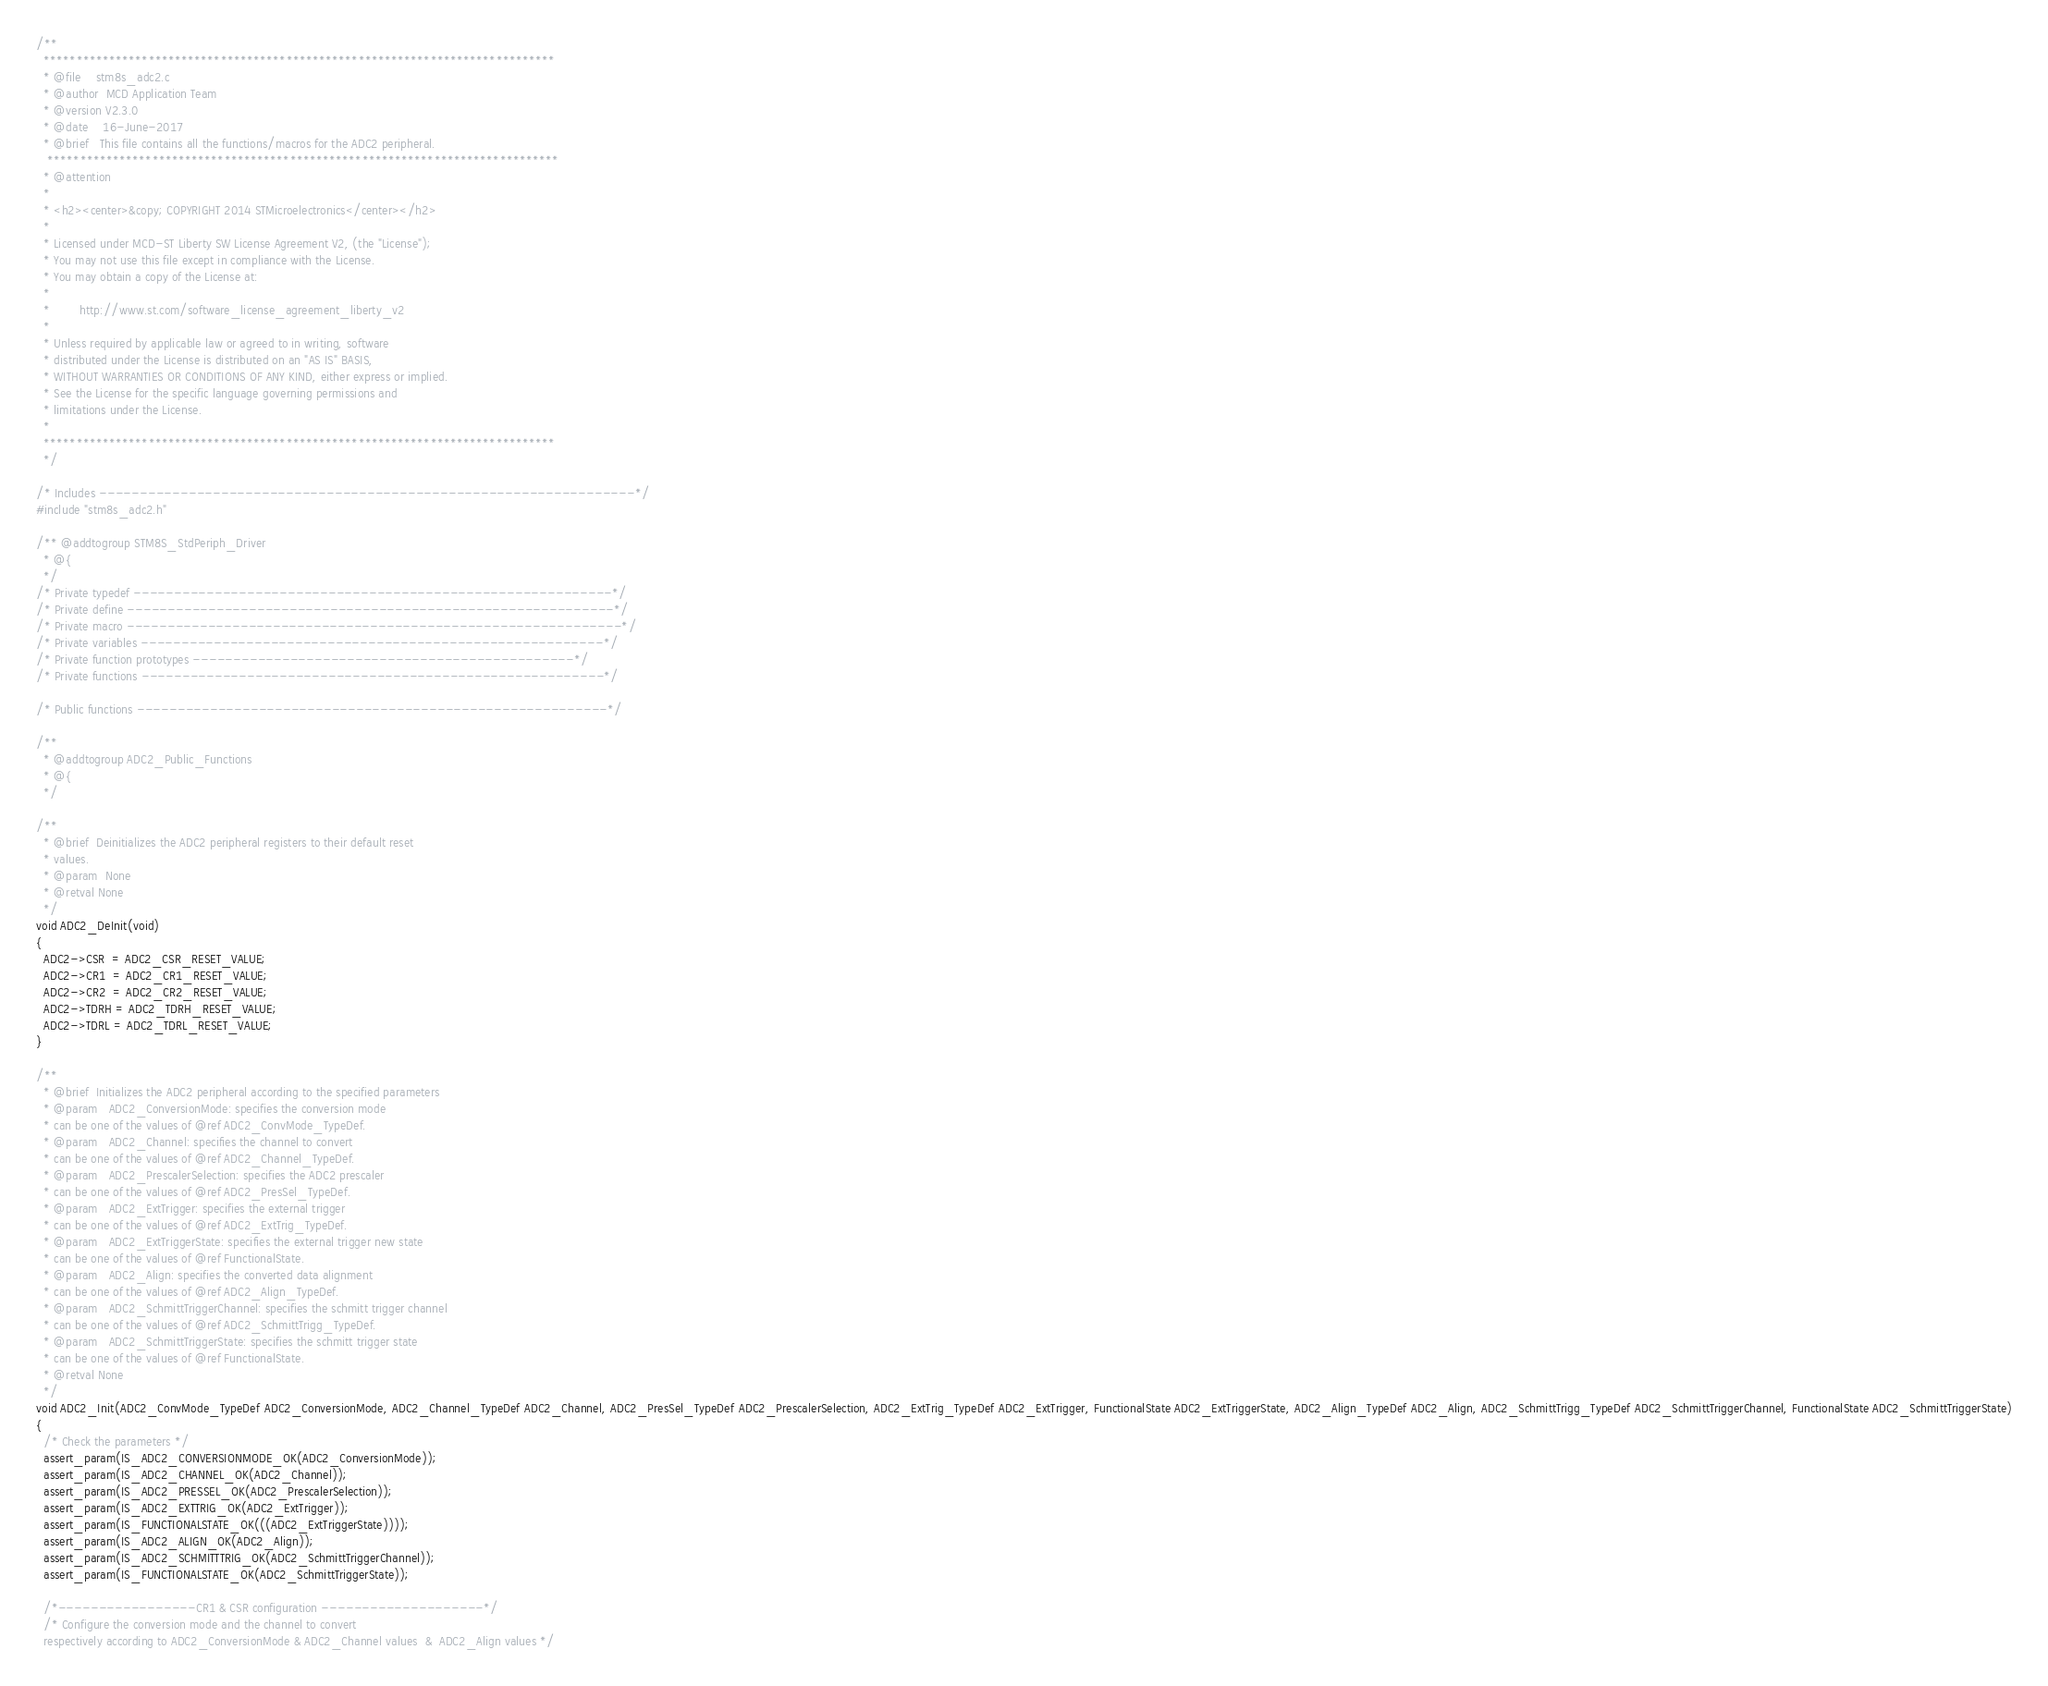<code> <loc_0><loc_0><loc_500><loc_500><_C_>/**
  ******************************************************************************
  * @file    stm8s_adc2.c
  * @author  MCD Application Team
  * @version V2.3.0
  * @date    16-June-2017
  * @brief   This file contains all the functions/macros for the ADC2 peripheral.
   ******************************************************************************
  * @attention
  *
  * <h2><center>&copy; COPYRIGHT 2014 STMicroelectronics</center></h2>
  *
  * Licensed under MCD-ST Liberty SW License Agreement V2, (the "License");
  * You may not use this file except in compliance with the License.
  * You may obtain a copy of the License at:
  *
  *        http://www.st.com/software_license_agreement_liberty_v2
  *
  * Unless required by applicable law or agreed to in writing, software 
  * distributed under the License is distributed on an "AS IS" BASIS, 
  * WITHOUT WARRANTIES OR CONDITIONS OF ANY KIND, either express or implied.
  * See the License for the specific language governing permissions and
  * limitations under the License.
  *
  ******************************************************************************
  */

/* Includes ------------------------------------------------------------------*/
#include "stm8s_adc2.h"

/** @addtogroup STM8S_StdPeriph_Driver
  * @{
  */
/* Private typedef -----------------------------------------------------------*/
/* Private define ------------------------------------------------------------*/
/* Private macro -------------------------------------------------------------*/
/* Private variables ---------------------------------------------------------*/
/* Private function prototypes -----------------------------------------------*/
/* Private functions ---------------------------------------------------------*/

/* Public functions ----------------------------------------------------------*/

/**
  * @addtogroup ADC2_Public_Functions
  * @{
  */

/**
  * @brief  Deinitializes the ADC2 peripheral registers to their default reset
  * values.
  * @param  None
  * @retval None
  */
void ADC2_DeInit(void)
{
  ADC2->CSR  = ADC2_CSR_RESET_VALUE;
  ADC2->CR1  = ADC2_CR1_RESET_VALUE;
  ADC2->CR2  = ADC2_CR2_RESET_VALUE;
  ADC2->TDRH = ADC2_TDRH_RESET_VALUE;
  ADC2->TDRL = ADC2_TDRL_RESET_VALUE;
}

/**
  * @brief  Initializes the ADC2 peripheral according to the specified parameters
  * @param   ADC2_ConversionMode: specifies the conversion mode
  * can be one of the values of @ref ADC2_ConvMode_TypeDef.
  * @param   ADC2_Channel: specifies the channel to convert
  * can be one of the values of @ref ADC2_Channel_TypeDef.
  * @param   ADC2_PrescalerSelection: specifies the ADC2 prescaler
  * can be one of the values of @ref ADC2_PresSel_TypeDef.
  * @param   ADC2_ExtTrigger: specifies the external trigger
  * can be one of the values of @ref ADC2_ExtTrig_TypeDef.
  * @param   ADC2_ExtTriggerState: specifies the external trigger new state
  * can be one of the values of @ref FunctionalState.
  * @param   ADC2_Align: specifies the converted data alignment
  * can be one of the values of @ref ADC2_Align_TypeDef.
  * @param   ADC2_SchmittTriggerChannel: specifies the schmitt trigger channel
  * can be one of the values of @ref ADC2_SchmittTrigg_TypeDef.
  * @param   ADC2_SchmittTriggerState: specifies the schmitt trigger state
  * can be one of the values of @ref FunctionalState.
  * @retval None
  */
void ADC2_Init(ADC2_ConvMode_TypeDef ADC2_ConversionMode, ADC2_Channel_TypeDef ADC2_Channel, ADC2_PresSel_TypeDef ADC2_PrescalerSelection, ADC2_ExtTrig_TypeDef ADC2_ExtTrigger, FunctionalState ADC2_ExtTriggerState, ADC2_Align_TypeDef ADC2_Align, ADC2_SchmittTrigg_TypeDef ADC2_SchmittTriggerChannel, FunctionalState ADC2_SchmittTriggerState)
{
  /* Check the parameters */
  assert_param(IS_ADC2_CONVERSIONMODE_OK(ADC2_ConversionMode));
  assert_param(IS_ADC2_CHANNEL_OK(ADC2_Channel));
  assert_param(IS_ADC2_PRESSEL_OK(ADC2_PrescalerSelection));
  assert_param(IS_ADC2_EXTTRIG_OK(ADC2_ExtTrigger));
  assert_param(IS_FUNCTIONALSTATE_OK(((ADC2_ExtTriggerState))));
  assert_param(IS_ADC2_ALIGN_OK(ADC2_Align));
  assert_param(IS_ADC2_SCHMITTTRIG_OK(ADC2_SchmittTriggerChannel));
  assert_param(IS_FUNCTIONALSTATE_OK(ADC2_SchmittTriggerState));
  
  /*-----------------CR1 & CSR configuration --------------------*/
  /* Configure the conversion mode and the channel to convert
  respectively according to ADC2_ConversionMode & ADC2_Channel values  &  ADC2_Align values */</code> 